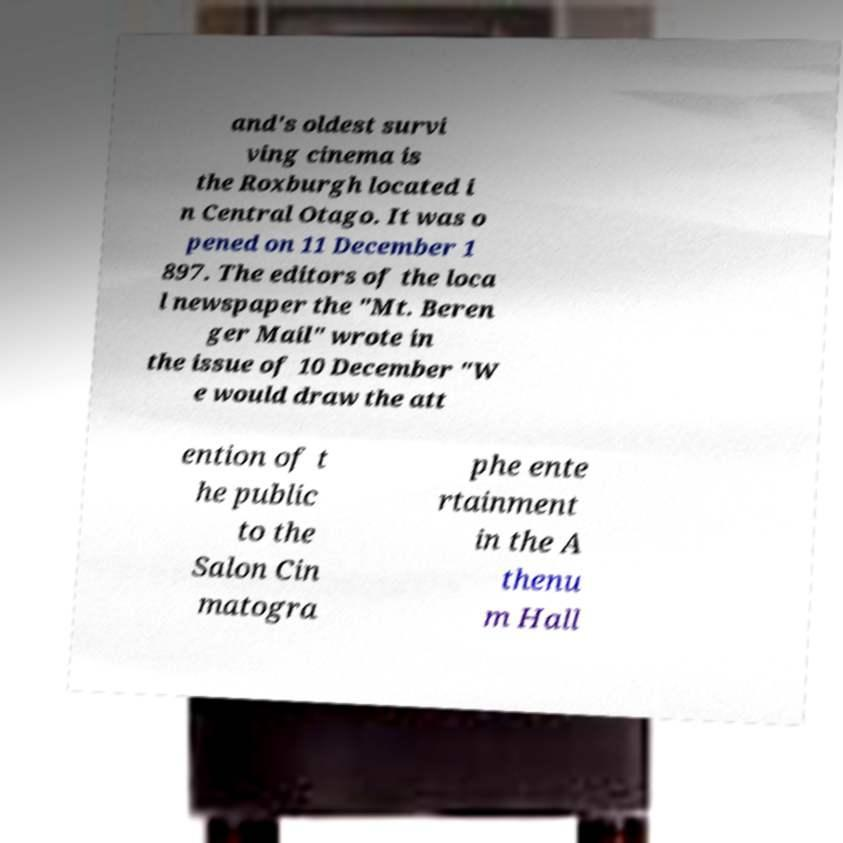Can you read and provide the text displayed in the image?This photo seems to have some interesting text. Can you extract and type it out for me? and's oldest survi ving cinema is the Roxburgh located i n Central Otago. It was o pened on 11 December 1 897. The editors of the loca l newspaper the "Mt. Beren ger Mail" wrote in the issue of 10 December "W e would draw the att ention of t he public to the Salon Cin matogra phe ente rtainment in the A thenu m Hall 